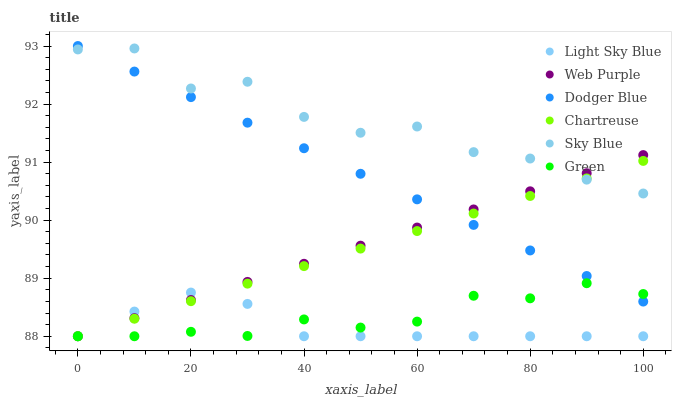Does Light Sky Blue have the minimum area under the curve?
Answer yes or no. Yes. Does Sky Blue have the maximum area under the curve?
Answer yes or no. Yes. Does Dodger Blue have the minimum area under the curve?
Answer yes or no. No. Does Dodger Blue have the maximum area under the curve?
Answer yes or no. No. Is Web Purple the smoothest?
Answer yes or no. Yes. Is Sky Blue the roughest?
Answer yes or no. Yes. Is Dodger Blue the smoothest?
Answer yes or no. No. Is Dodger Blue the roughest?
Answer yes or no. No. Does Chartreuse have the lowest value?
Answer yes or no. Yes. Does Dodger Blue have the lowest value?
Answer yes or no. No. Does Dodger Blue have the highest value?
Answer yes or no. Yes. Does Web Purple have the highest value?
Answer yes or no. No. Is Light Sky Blue less than Sky Blue?
Answer yes or no. Yes. Is Sky Blue greater than Green?
Answer yes or no. Yes. Does Chartreuse intersect Dodger Blue?
Answer yes or no. Yes. Is Chartreuse less than Dodger Blue?
Answer yes or no. No. Is Chartreuse greater than Dodger Blue?
Answer yes or no. No. Does Light Sky Blue intersect Sky Blue?
Answer yes or no. No. 